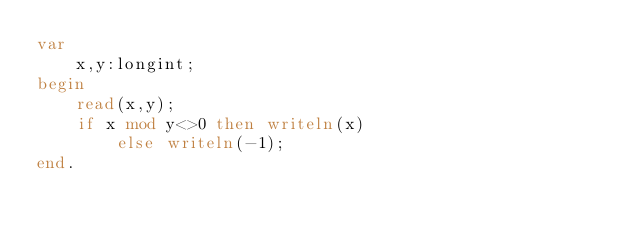Convert code to text. <code><loc_0><loc_0><loc_500><loc_500><_Pascal_>var
    x,y:longint;
begin
    read(x,y);
    if x mod y<>0 then writeln(x)
        else writeln(-1);
end.</code> 